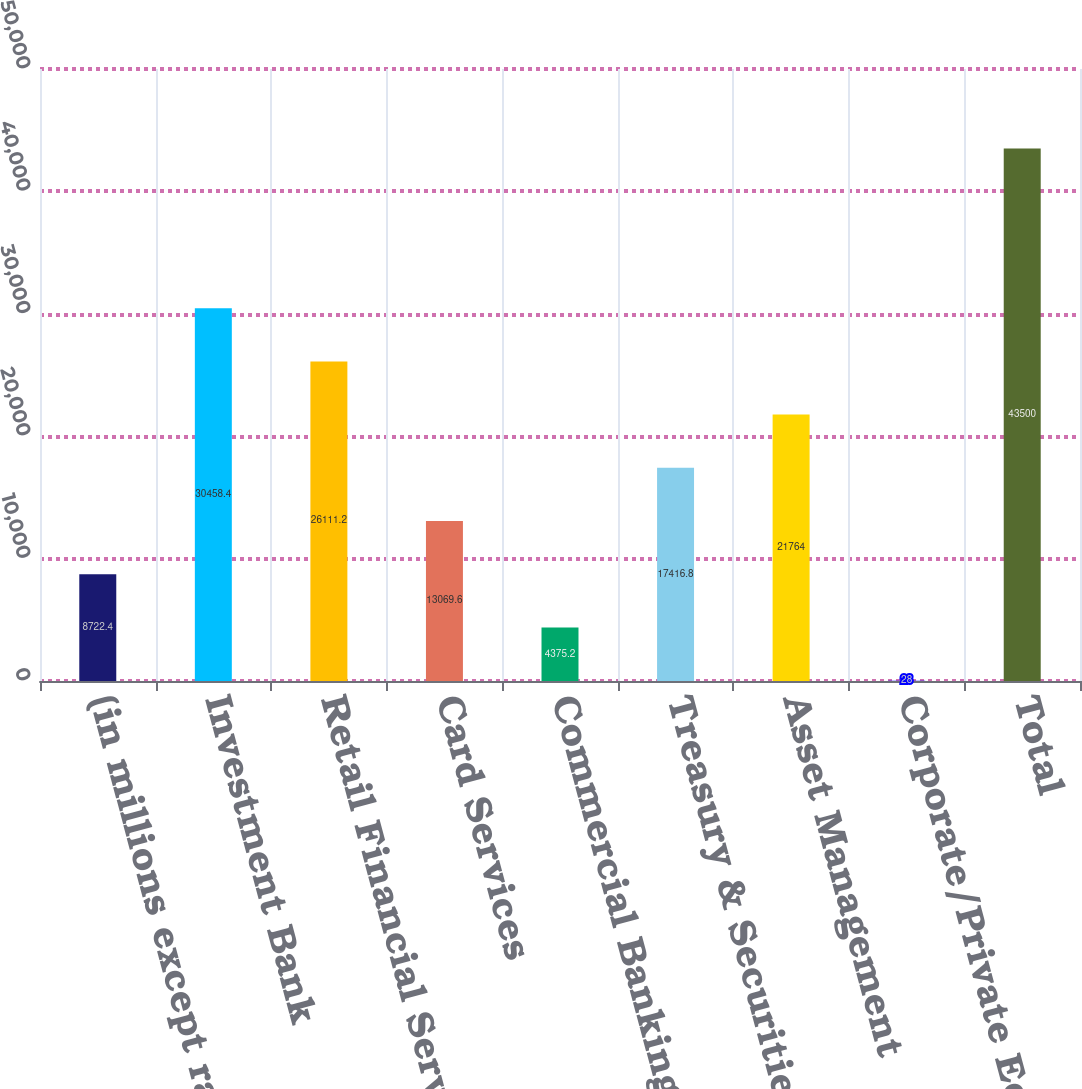Convert chart. <chart><loc_0><loc_0><loc_500><loc_500><bar_chart><fcel>(in millions except ratios)<fcel>Investment Bank<fcel>Retail Financial Services<fcel>Card Services<fcel>Commercial Banking<fcel>Treasury & Securities Services<fcel>Asset Management<fcel>Corporate/Private Equity<fcel>Total<nl><fcel>8722.4<fcel>30458.4<fcel>26111.2<fcel>13069.6<fcel>4375.2<fcel>17416.8<fcel>21764<fcel>28<fcel>43500<nl></chart> 